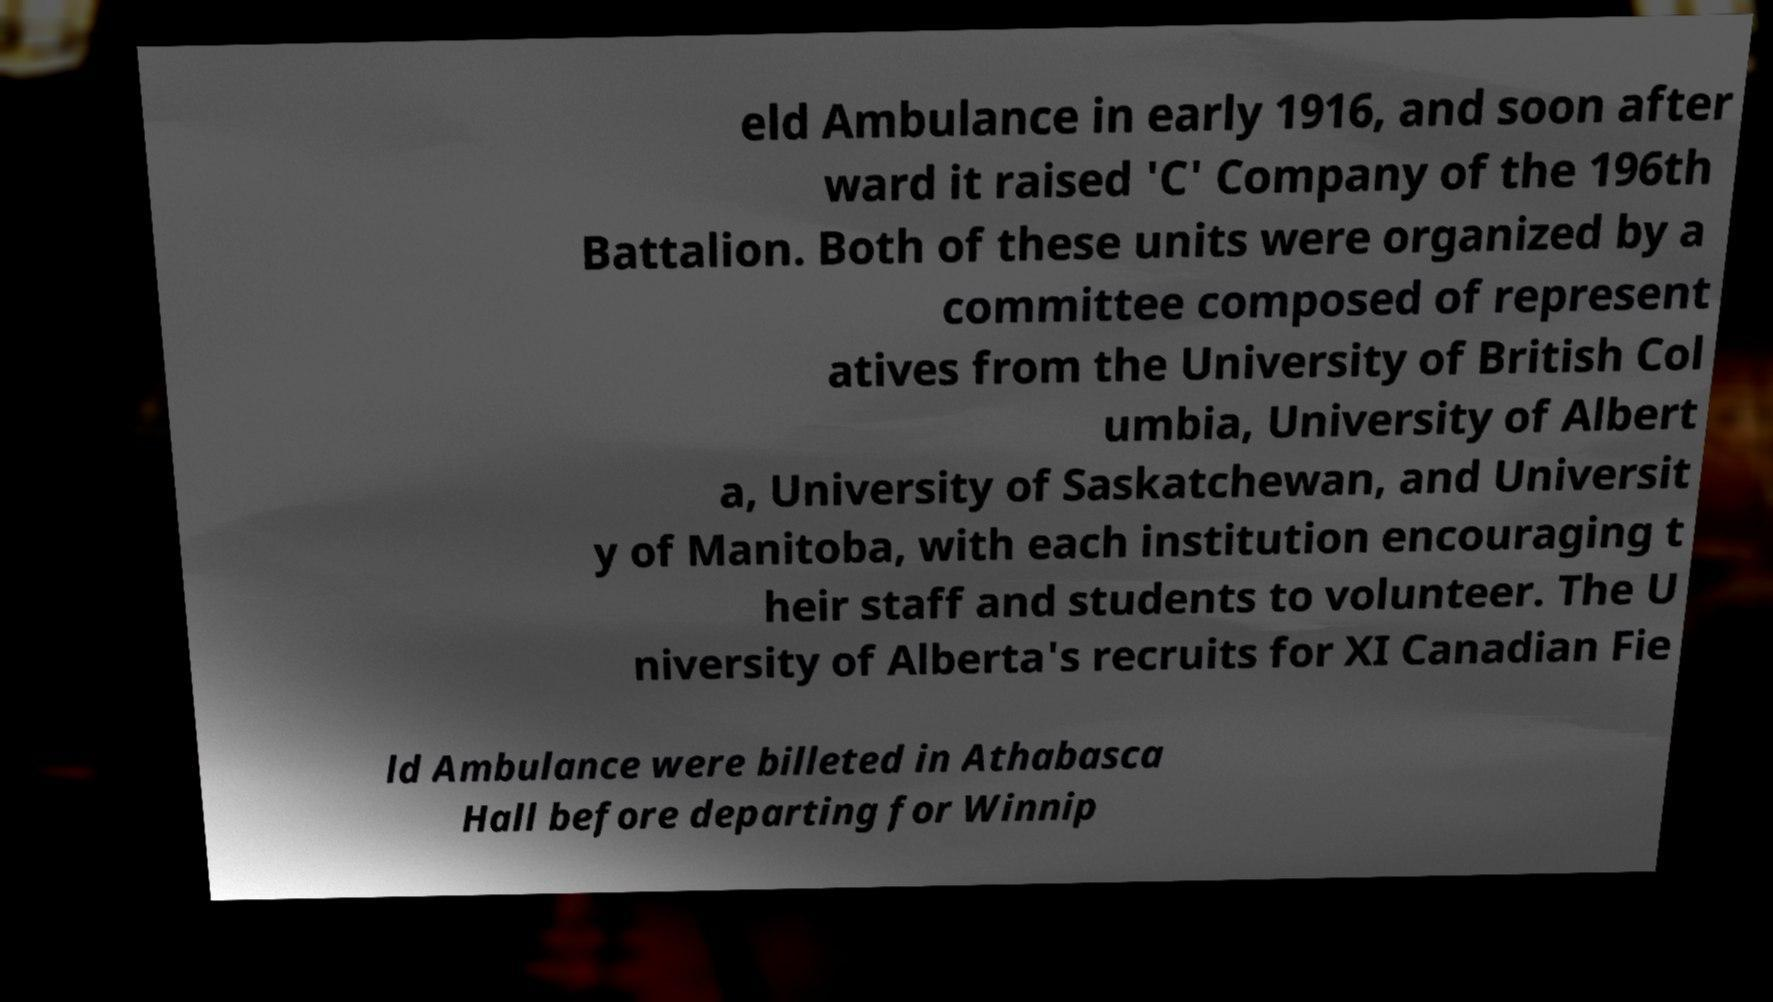Please identify and transcribe the text found in this image. eld Ambulance in early 1916, and soon after ward it raised 'C' Company of the 196th Battalion. Both of these units were organized by a committee composed of represent atives from the University of British Col umbia, University of Albert a, University of Saskatchewan, and Universit y of Manitoba, with each institution encouraging t heir staff and students to volunteer. The U niversity of Alberta's recruits for XI Canadian Fie ld Ambulance were billeted in Athabasca Hall before departing for Winnip 